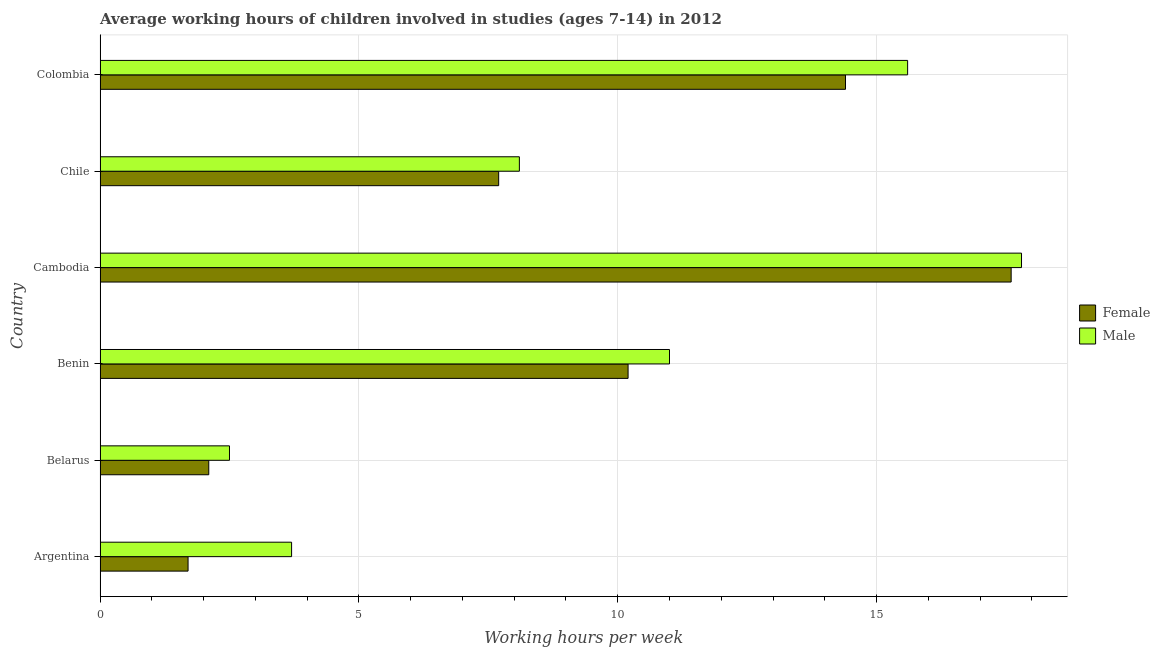How many groups of bars are there?
Your answer should be compact. 6. Are the number of bars per tick equal to the number of legend labels?
Give a very brief answer. Yes. How many bars are there on the 6th tick from the bottom?
Your answer should be very brief. 2. What is the label of the 3rd group of bars from the top?
Your response must be concise. Cambodia. In how many cases, is the number of bars for a given country not equal to the number of legend labels?
Your answer should be very brief. 0. What is the average working hour of female children in Benin?
Make the answer very short. 10.2. Across all countries, what is the maximum average working hour of male children?
Provide a short and direct response. 17.8. In which country was the average working hour of female children maximum?
Your answer should be compact. Cambodia. In which country was the average working hour of female children minimum?
Offer a very short reply. Argentina. What is the total average working hour of female children in the graph?
Keep it short and to the point. 53.7. What is the difference between the average working hour of female children in Chile and that in Colombia?
Offer a very short reply. -6.7. What is the difference between the average working hour of male children in Argentina and the average working hour of female children in Cambodia?
Your answer should be compact. -13.9. What is the average average working hour of female children per country?
Your response must be concise. 8.95. What is the difference between the average working hour of male children and average working hour of female children in Benin?
Provide a short and direct response. 0.8. In how many countries, is the average working hour of female children greater than 10 hours?
Offer a terse response. 3. What is the ratio of the average working hour of female children in Argentina to that in Colombia?
Provide a succinct answer. 0.12. What is the difference between the highest and the lowest average working hour of female children?
Keep it short and to the point. 15.9. In how many countries, is the average working hour of female children greater than the average average working hour of female children taken over all countries?
Your answer should be compact. 3. What does the 2nd bar from the top in Belarus represents?
Provide a short and direct response. Female. What does the 2nd bar from the bottom in Cambodia represents?
Provide a succinct answer. Male. How many countries are there in the graph?
Keep it short and to the point. 6. Does the graph contain any zero values?
Your answer should be very brief. No. Does the graph contain grids?
Ensure brevity in your answer.  Yes. What is the title of the graph?
Keep it short and to the point. Average working hours of children involved in studies (ages 7-14) in 2012. What is the label or title of the X-axis?
Ensure brevity in your answer.  Working hours per week. What is the Working hours per week in Female in Argentina?
Make the answer very short. 1.7. What is the Working hours per week of Male in Argentina?
Give a very brief answer. 3.7. What is the Working hours per week in Female in Belarus?
Provide a short and direct response. 2.1. What is the Working hours per week of Male in Belarus?
Your response must be concise. 2.5. What is the Working hours per week of Female in Benin?
Your answer should be very brief. 10.2. What is the Working hours per week in Male in Benin?
Give a very brief answer. 11. What is the Working hours per week in Male in Chile?
Keep it short and to the point. 8.1. What is the Working hours per week of Female in Colombia?
Make the answer very short. 14.4. What is the Working hours per week in Male in Colombia?
Provide a succinct answer. 15.6. What is the total Working hours per week of Female in the graph?
Offer a very short reply. 53.7. What is the total Working hours per week of Male in the graph?
Provide a short and direct response. 58.7. What is the difference between the Working hours per week in Female in Argentina and that in Belarus?
Your answer should be very brief. -0.4. What is the difference between the Working hours per week of Female in Argentina and that in Cambodia?
Keep it short and to the point. -15.9. What is the difference between the Working hours per week of Male in Argentina and that in Cambodia?
Offer a terse response. -14.1. What is the difference between the Working hours per week in Male in Argentina and that in Chile?
Your answer should be very brief. -4.4. What is the difference between the Working hours per week of Female in Argentina and that in Colombia?
Keep it short and to the point. -12.7. What is the difference between the Working hours per week in Male in Argentina and that in Colombia?
Provide a short and direct response. -11.9. What is the difference between the Working hours per week of Female in Belarus and that in Benin?
Offer a terse response. -8.1. What is the difference between the Working hours per week in Male in Belarus and that in Benin?
Ensure brevity in your answer.  -8.5. What is the difference between the Working hours per week of Female in Belarus and that in Cambodia?
Provide a succinct answer. -15.5. What is the difference between the Working hours per week in Male in Belarus and that in Cambodia?
Your response must be concise. -15.3. What is the difference between the Working hours per week in Female in Belarus and that in Chile?
Offer a terse response. -5.6. What is the difference between the Working hours per week in Male in Belarus and that in Chile?
Your answer should be very brief. -5.6. What is the difference between the Working hours per week of Female in Cambodia and that in Chile?
Keep it short and to the point. 9.9. What is the difference between the Working hours per week in Male in Cambodia and that in Chile?
Your answer should be compact. 9.7. What is the difference between the Working hours per week of Female in Cambodia and that in Colombia?
Provide a succinct answer. 3.2. What is the difference between the Working hours per week of Female in Chile and that in Colombia?
Give a very brief answer. -6.7. What is the difference between the Working hours per week in Male in Chile and that in Colombia?
Keep it short and to the point. -7.5. What is the difference between the Working hours per week of Female in Argentina and the Working hours per week of Male in Cambodia?
Give a very brief answer. -16.1. What is the difference between the Working hours per week of Female in Belarus and the Working hours per week of Male in Cambodia?
Provide a succinct answer. -15.7. What is the difference between the Working hours per week of Female in Belarus and the Working hours per week of Male in Colombia?
Give a very brief answer. -13.5. What is the difference between the Working hours per week in Female in Benin and the Working hours per week in Male in Cambodia?
Provide a succinct answer. -7.6. What is the average Working hours per week of Female per country?
Offer a terse response. 8.95. What is the average Working hours per week in Male per country?
Provide a short and direct response. 9.78. What is the difference between the Working hours per week of Female and Working hours per week of Male in Argentina?
Provide a succinct answer. -2. What is the difference between the Working hours per week in Female and Working hours per week in Male in Belarus?
Your response must be concise. -0.4. What is the difference between the Working hours per week of Female and Working hours per week of Male in Benin?
Keep it short and to the point. -0.8. What is the difference between the Working hours per week of Female and Working hours per week of Male in Cambodia?
Offer a terse response. -0.2. What is the ratio of the Working hours per week of Female in Argentina to that in Belarus?
Offer a terse response. 0.81. What is the ratio of the Working hours per week of Male in Argentina to that in Belarus?
Your response must be concise. 1.48. What is the ratio of the Working hours per week in Male in Argentina to that in Benin?
Keep it short and to the point. 0.34. What is the ratio of the Working hours per week in Female in Argentina to that in Cambodia?
Offer a very short reply. 0.1. What is the ratio of the Working hours per week in Male in Argentina to that in Cambodia?
Offer a very short reply. 0.21. What is the ratio of the Working hours per week in Female in Argentina to that in Chile?
Keep it short and to the point. 0.22. What is the ratio of the Working hours per week of Male in Argentina to that in Chile?
Make the answer very short. 0.46. What is the ratio of the Working hours per week in Female in Argentina to that in Colombia?
Give a very brief answer. 0.12. What is the ratio of the Working hours per week in Male in Argentina to that in Colombia?
Provide a succinct answer. 0.24. What is the ratio of the Working hours per week of Female in Belarus to that in Benin?
Your answer should be very brief. 0.21. What is the ratio of the Working hours per week of Male in Belarus to that in Benin?
Keep it short and to the point. 0.23. What is the ratio of the Working hours per week of Female in Belarus to that in Cambodia?
Provide a succinct answer. 0.12. What is the ratio of the Working hours per week of Male in Belarus to that in Cambodia?
Offer a terse response. 0.14. What is the ratio of the Working hours per week of Female in Belarus to that in Chile?
Your answer should be very brief. 0.27. What is the ratio of the Working hours per week of Male in Belarus to that in Chile?
Provide a succinct answer. 0.31. What is the ratio of the Working hours per week of Female in Belarus to that in Colombia?
Ensure brevity in your answer.  0.15. What is the ratio of the Working hours per week in Male in Belarus to that in Colombia?
Offer a very short reply. 0.16. What is the ratio of the Working hours per week in Female in Benin to that in Cambodia?
Make the answer very short. 0.58. What is the ratio of the Working hours per week in Male in Benin to that in Cambodia?
Make the answer very short. 0.62. What is the ratio of the Working hours per week of Female in Benin to that in Chile?
Give a very brief answer. 1.32. What is the ratio of the Working hours per week in Male in Benin to that in Chile?
Give a very brief answer. 1.36. What is the ratio of the Working hours per week in Female in Benin to that in Colombia?
Provide a short and direct response. 0.71. What is the ratio of the Working hours per week in Male in Benin to that in Colombia?
Provide a short and direct response. 0.71. What is the ratio of the Working hours per week of Female in Cambodia to that in Chile?
Give a very brief answer. 2.29. What is the ratio of the Working hours per week in Male in Cambodia to that in Chile?
Provide a succinct answer. 2.2. What is the ratio of the Working hours per week of Female in Cambodia to that in Colombia?
Offer a very short reply. 1.22. What is the ratio of the Working hours per week in Male in Cambodia to that in Colombia?
Your response must be concise. 1.14. What is the ratio of the Working hours per week in Female in Chile to that in Colombia?
Make the answer very short. 0.53. What is the ratio of the Working hours per week of Male in Chile to that in Colombia?
Make the answer very short. 0.52. What is the difference between the highest and the second highest Working hours per week of Female?
Offer a terse response. 3.2. What is the difference between the highest and the lowest Working hours per week of Male?
Keep it short and to the point. 15.3. 